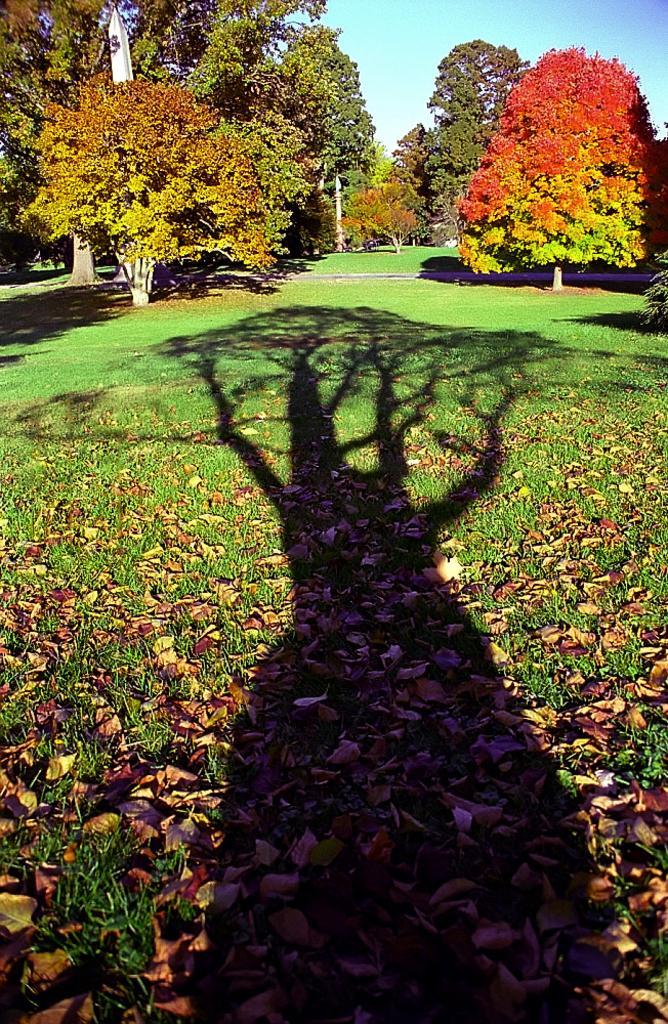Describe this image in one or two sentences. In the image we can see there is a shadow of a tree on the ground and the ground is covered with dry leaves and grass. Behind there are trees and there is a clear sky. 